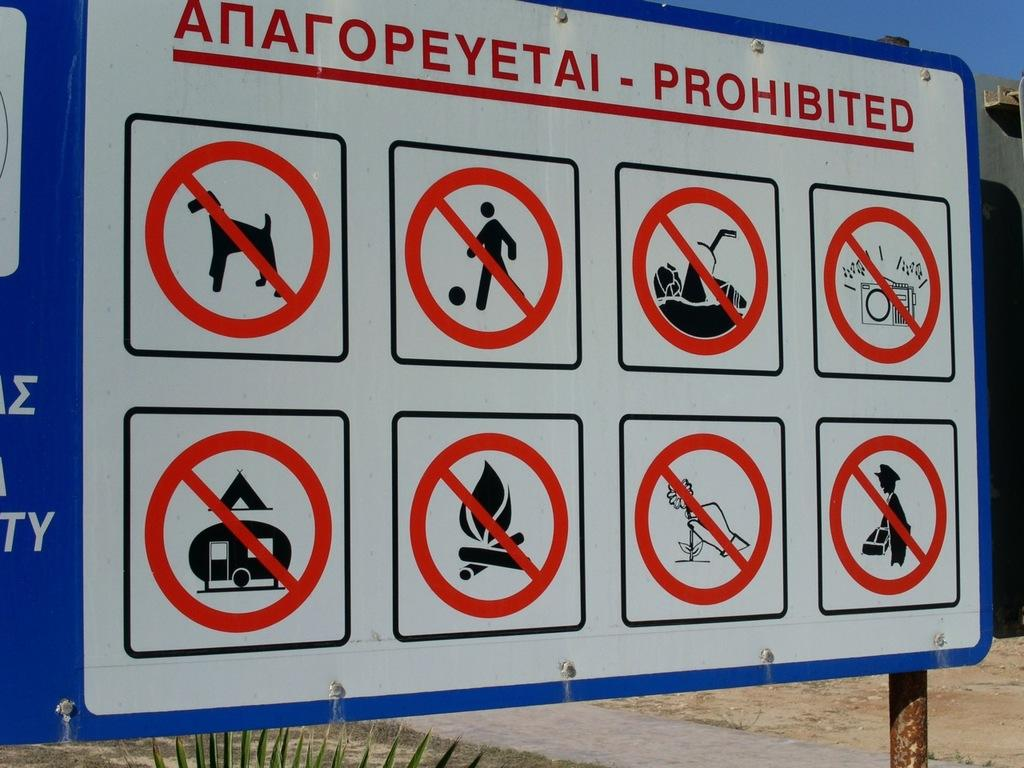<image>
Give a short and clear explanation of the subsequent image. A large sign shows PROHIBITED things such as dogs, fires, and picking flowers. 